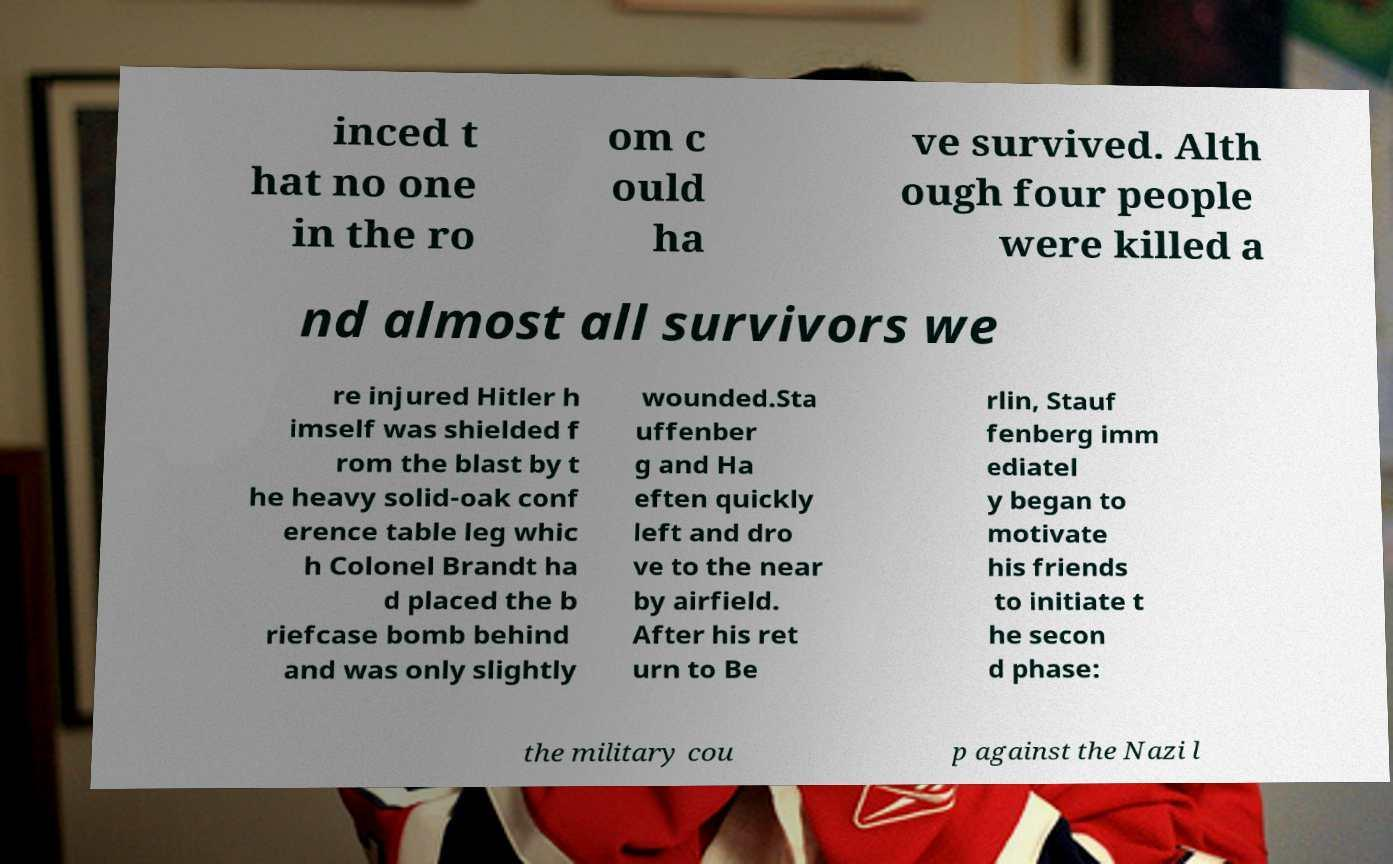Please read and relay the text visible in this image. What does it say? inced t hat no one in the ro om c ould ha ve survived. Alth ough four people were killed a nd almost all survivors we re injured Hitler h imself was shielded f rom the blast by t he heavy solid-oak conf erence table leg whic h Colonel Brandt ha d placed the b riefcase bomb behind and was only slightly wounded.Sta uffenber g and Ha eften quickly left and dro ve to the near by airfield. After his ret urn to Be rlin, Stauf fenberg imm ediatel y began to motivate his friends to initiate t he secon d phase: the military cou p against the Nazi l 